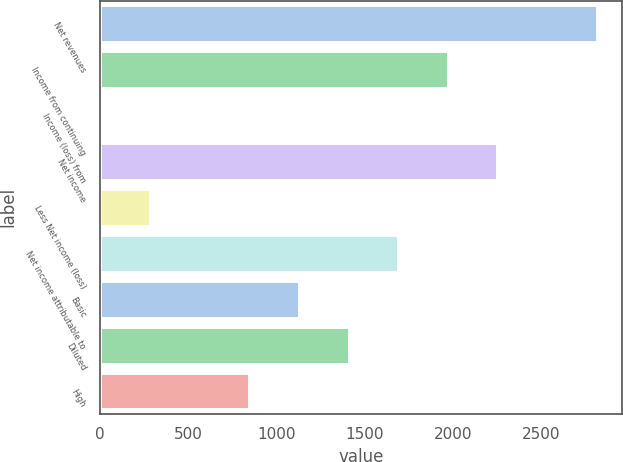Convert chart to OTSL. <chart><loc_0><loc_0><loc_500><loc_500><bar_chart><fcel>Net revenues<fcel>Income from continuing<fcel>Income (loss) from<fcel>Net income<fcel>Less Net income (loss)<fcel>Net income attributable to<fcel>Basic<fcel>Diluted<fcel>High<nl><fcel>2813<fcel>1969.4<fcel>1<fcel>2250.6<fcel>282.2<fcel>1688.2<fcel>1125.8<fcel>1407<fcel>844.6<nl></chart> 